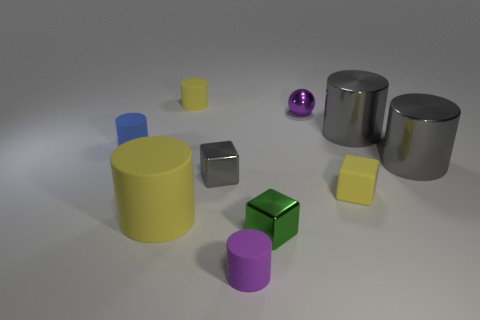Subtract all purple cylinders. How many cylinders are left? 5 Subtract 3 cylinders. How many cylinders are left? 3 Subtract all spheres. How many objects are left? 9 Subtract all yellow cubes. How many gray cylinders are left? 2 Subtract all gray cylinders. How many cylinders are left? 4 Subtract all small red matte cylinders. Subtract all rubber cylinders. How many objects are left? 6 Add 8 blue cylinders. How many blue cylinders are left? 9 Add 7 tiny yellow rubber cylinders. How many tiny yellow rubber cylinders exist? 8 Subtract 0 cyan balls. How many objects are left? 10 Subtract all blue cubes. Subtract all blue spheres. How many cubes are left? 3 